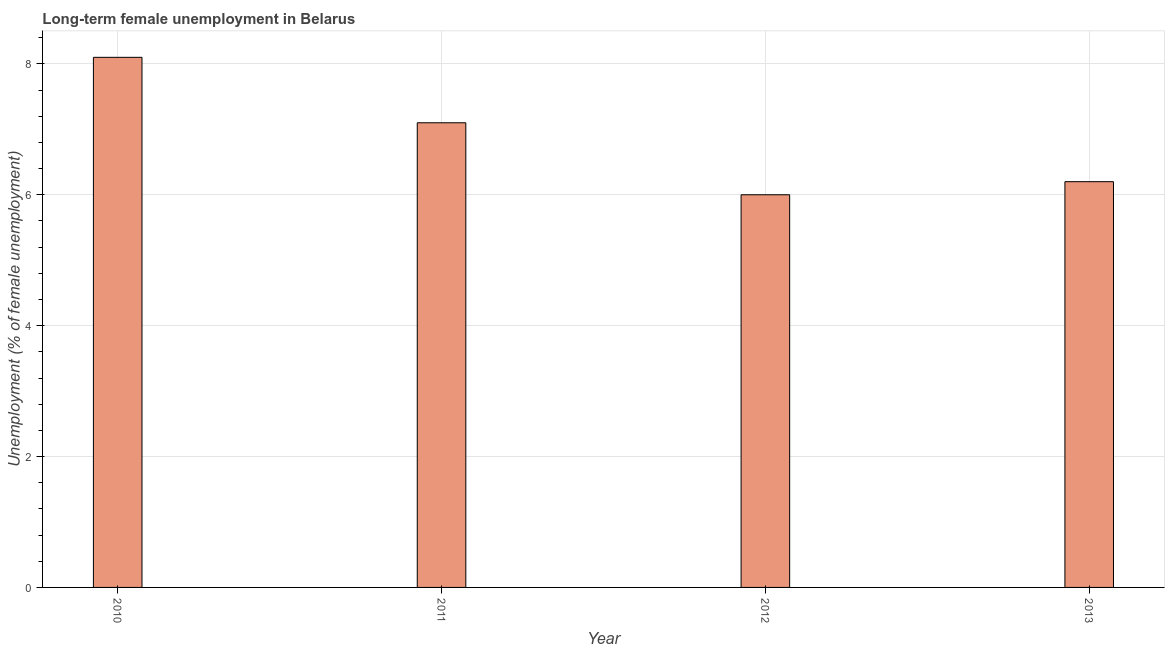Does the graph contain any zero values?
Provide a succinct answer. No. Does the graph contain grids?
Ensure brevity in your answer.  Yes. What is the title of the graph?
Keep it short and to the point. Long-term female unemployment in Belarus. What is the label or title of the X-axis?
Your answer should be compact. Year. What is the label or title of the Y-axis?
Keep it short and to the point. Unemployment (% of female unemployment). What is the long-term female unemployment in 2011?
Offer a terse response. 7.1. Across all years, what is the maximum long-term female unemployment?
Your answer should be compact. 8.1. In which year was the long-term female unemployment maximum?
Offer a very short reply. 2010. What is the sum of the long-term female unemployment?
Your answer should be compact. 27.4. What is the average long-term female unemployment per year?
Keep it short and to the point. 6.85. What is the median long-term female unemployment?
Provide a short and direct response. 6.65. What is the ratio of the long-term female unemployment in 2010 to that in 2011?
Provide a succinct answer. 1.14. Is the difference between the long-term female unemployment in 2011 and 2012 greater than the difference between any two years?
Your response must be concise. No. Are the values on the major ticks of Y-axis written in scientific E-notation?
Ensure brevity in your answer.  No. What is the Unemployment (% of female unemployment) of 2010?
Provide a short and direct response. 8.1. What is the Unemployment (% of female unemployment) of 2011?
Keep it short and to the point. 7.1. What is the Unemployment (% of female unemployment) in 2012?
Your answer should be very brief. 6. What is the Unemployment (% of female unemployment) of 2013?
Ensure brevity in your answer.  6.2. What is the difference between the Unemployment (% of female unemployment) in 2010 and 2012?
Keep it short and to the point. 2.1. What is the difference between the Unemployment (% of female unemployment) in 2011 and 2013?
Give a very brief answer. 0.9. What is the ratio of the Unemployment (% of female unemployment) in 2010 to that in 2011?
Make the answer very short. 1.14. What is the ratio of the Unemployment (% of female unemployment) in 2010 to that in 2012?
Give a very brief answer. 1.35. What is the ratio of the Unemployment (% of female unemployment) in 2010 to that in 2013?
Offer a very short reply. 1.31. What is the ratio of the Unemployment (% of female unemployment) in 2011 to that in 2012?
Keep it short and to the point. 1.18. What is the ratio of the Unemployment (% of female unemployment) in 2011 to that in 2013?
Keep it short and to the point. 1.15. 